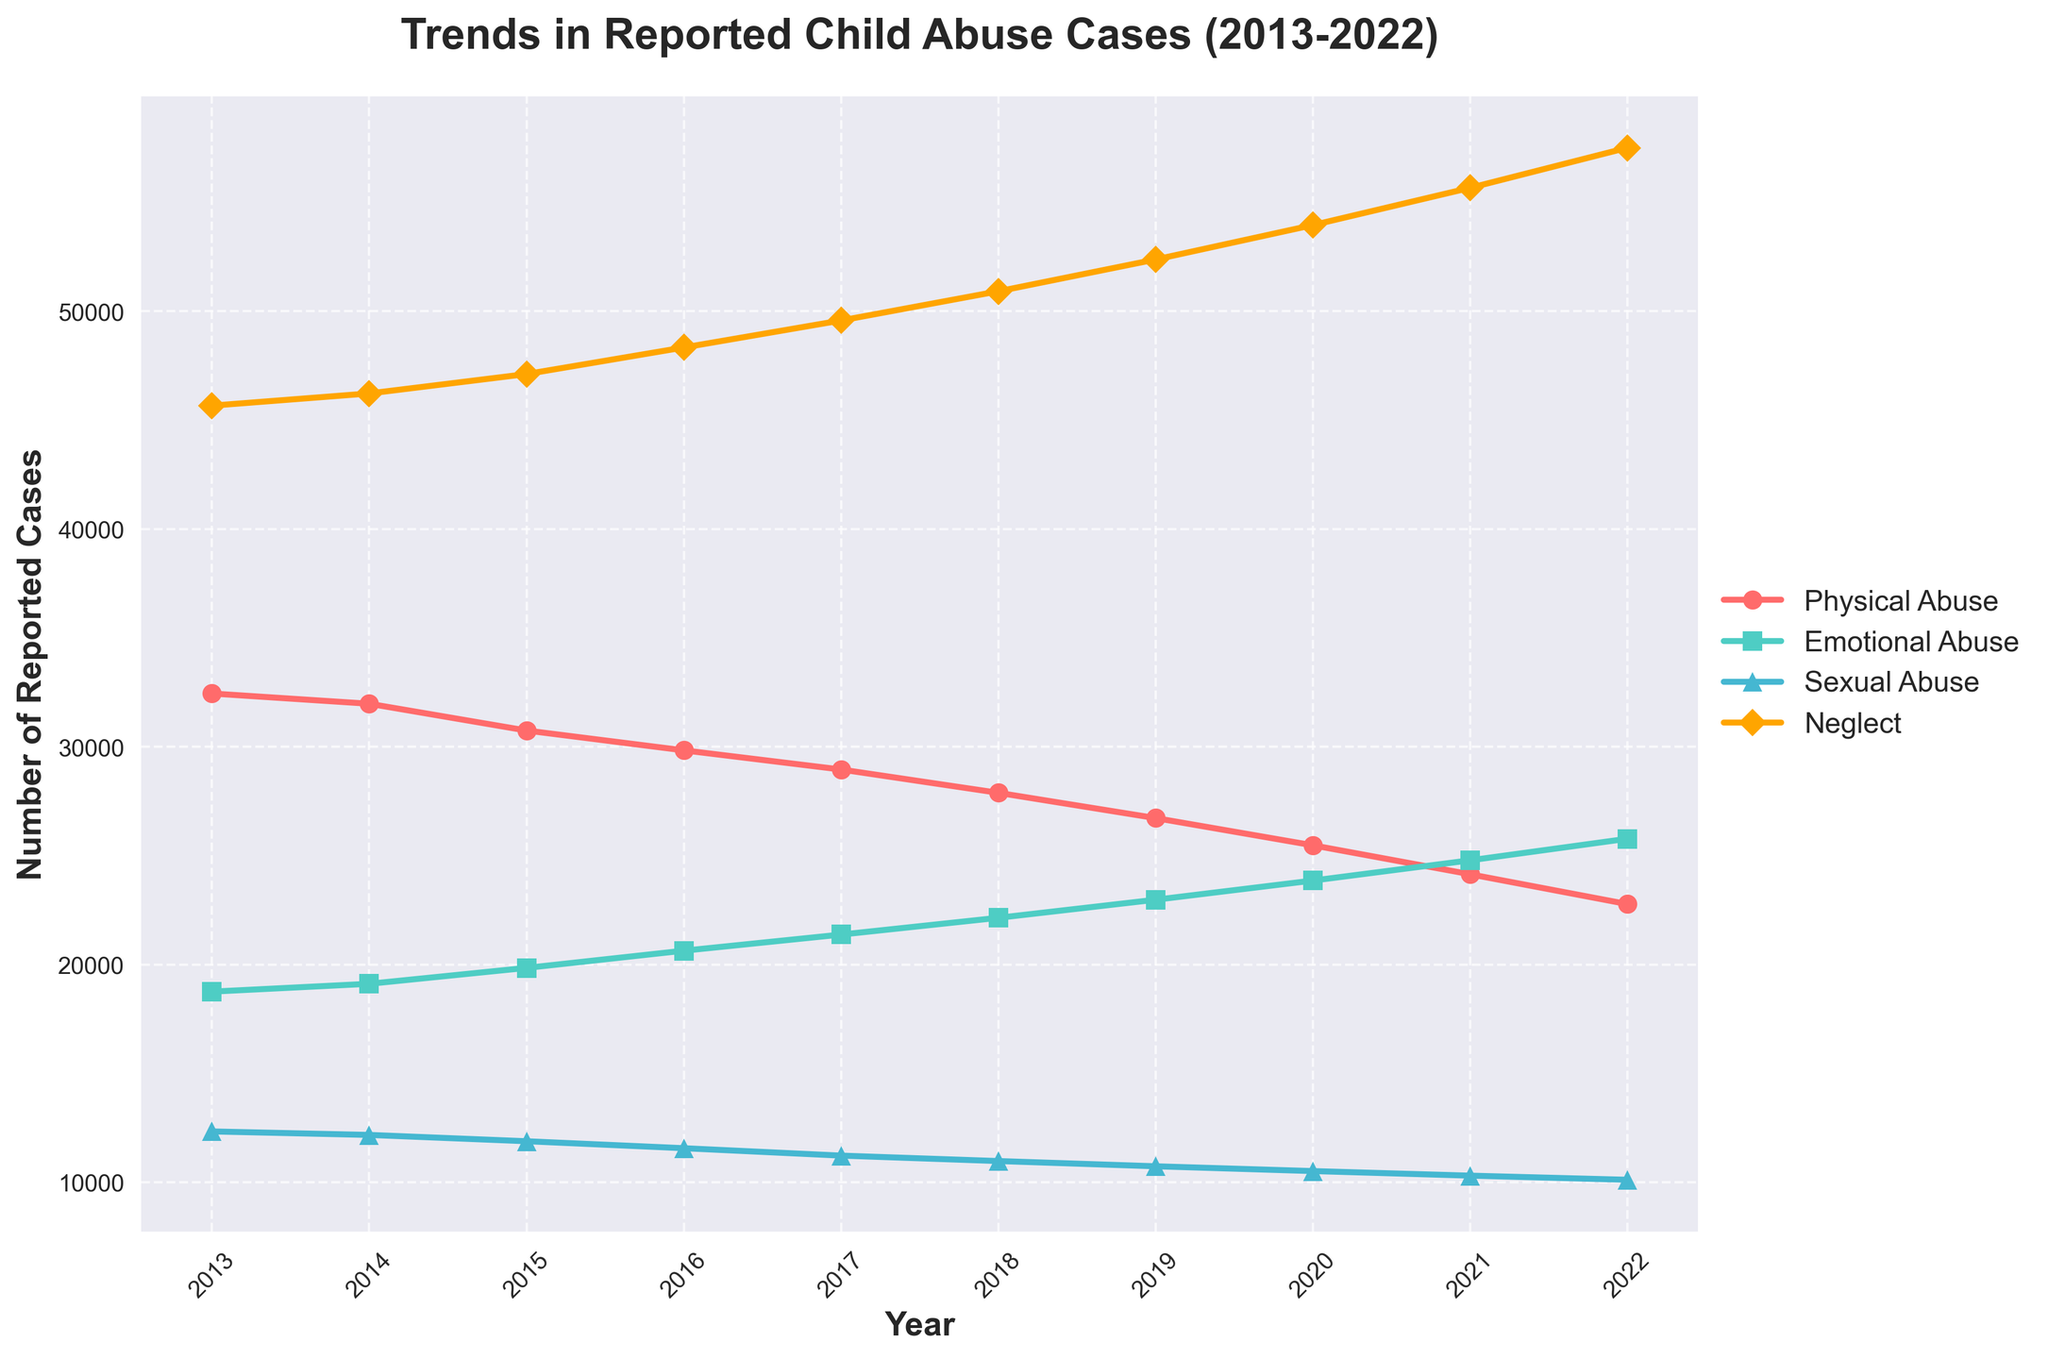How did the trends in reported physical abuse cases change over the decade? The plot shows a clear downward trend in reported physical abuse cases from 2013 to 2022. By observing the graph, the number of cases in 2013 was around 32,450, which gradually decreased each year until reaching approximately 22,780 in 2022. Thus, the trend indicates a consistent decline.
Answer: Decreased consistently In which year did emotional abuse cases surpass physical abuse cases? To answer this, compare the lines for emotional and physical abuse. Initially, physical abuse starts higher, but emotional abuse increases each year. The two lines cross around 2016, where emotional abuse cases were about 20,640 and physical abuse cases were about 29,840. Therefore, 2016 is the year when emotional abuse cases surpassed physical abuse cases.
Answer: 2016 Which type of abuse showed the most significant increase over the decade? To determine this, observe the overall trend lines for all abuse types. Emotional abuse shows a strong upward trend from approximately 18,760 cases in 2013 to about 25,780 in 2022. By comparison, the increase in neglect and reductions in physical and sexual abuse make emotional abuse the most significantly increased type over the decade.
Answer: Emotional abuse Which year had the most reported neglect cases? Looking at the plot, the line for neglect shows a consistent upward trend. The highest point on this line is in the year 2022, where the reported cases peaked at around 57,510.
Answer: 2022 What is the combined number of reported abuse cases (all types) in 2017? To find this, sum the number of cases for each abuse type in 2017. Physical abuse (28,960) + Emotional abuse (21,380) + Sexual abuse (11,230) + Neglect (49,580) totals to 111,150 reported cases.
Answer: 111,150 In what year did reported sexual abuse cases drop below 11,000? By examining the line for sexual abuse, we see that the reported cases dropped below 11,000 in the year 2018, where the number of cases was 10,980.
Answer: 2018 Which type of abuse had the smallest variation in the number of reported cases over the decade? To figure this out, observe the range of values for each type of abuse. Sexual abuse shows the least variation, starting at 12,340 in 2013 and only slightly decreasing to 10,120 by 2022. This makes sexual abuse the type with the smallest variation in reported cases.
Answer: Sexual abuse Compare the trends in emotional abuse and physical abuse from 2013 to 2017. From 2013 to 2017, physical abuse cases show a downward trend, decreasing from 32,450 to 28,960. Emotional abuse, however, shows an upward trend, increasing from 18,760 to 21,380. Therefore, physical abuse decreased while emotional abuse increased during this period.
Answer: Physical abuse decreased, Emotional abuse increased What is the average number of reported neglect cases per year? To compute the average, add the number of neglect cases for all years and then divide by the number of years. Sum of neglect cases (45,670 + 46,230 + 47,120 + 48,340 + 49,580 + 50,920 + 52,380 + 53,960 + 55,670 + 57,510) equals 507,380. Divided by 10 (years), the average is 50,738.
Answer: 50,738 